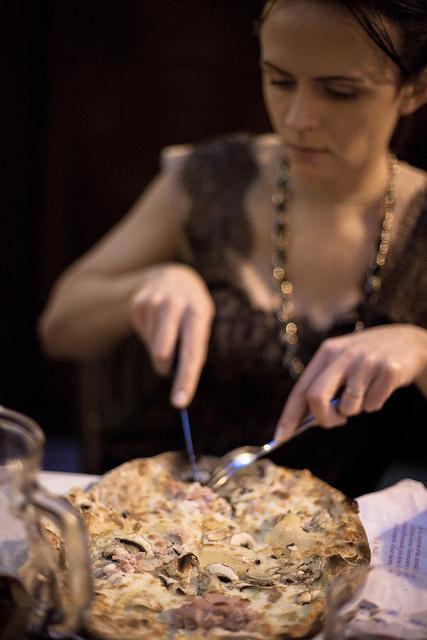How many books are in the room?
Give a very brief answer. 0. 